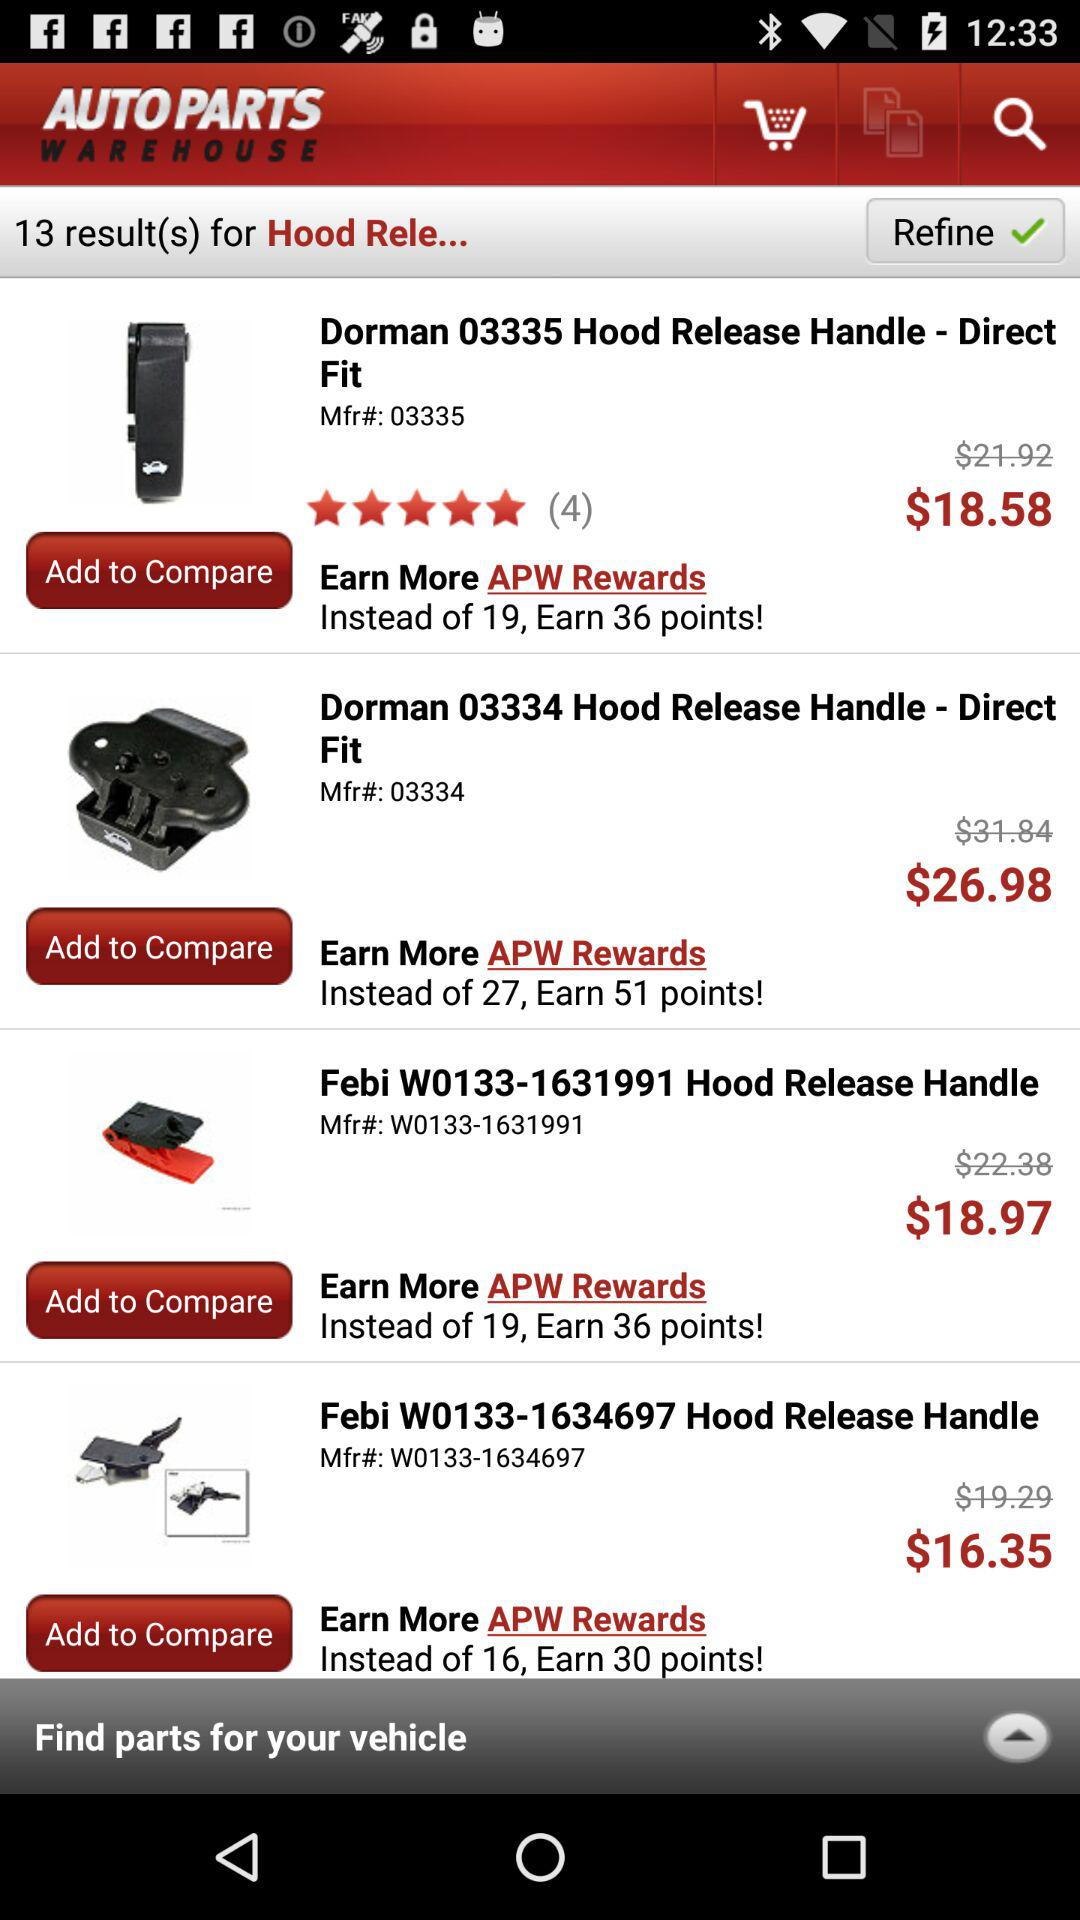How many point I will earn through APW rewards?
When the provided information is insufficient, respond with <no answer>. <no answer> 